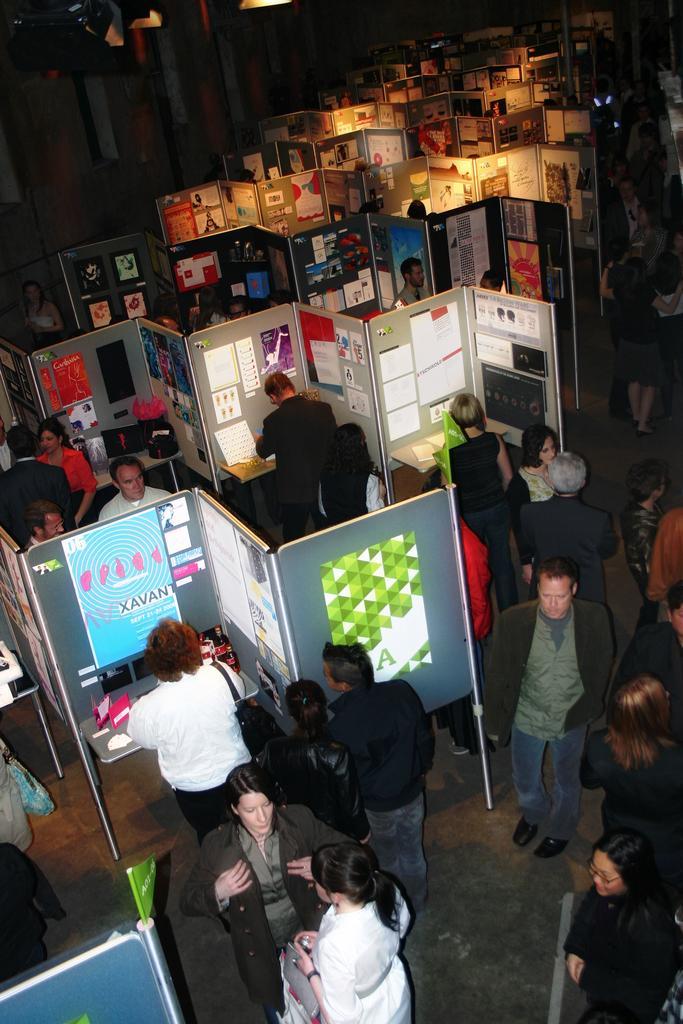How would you summarize this image in a sentence or two? In this picture we can see a group of people standing on the ground and in front of them we can see posters and in the background it is dark. 